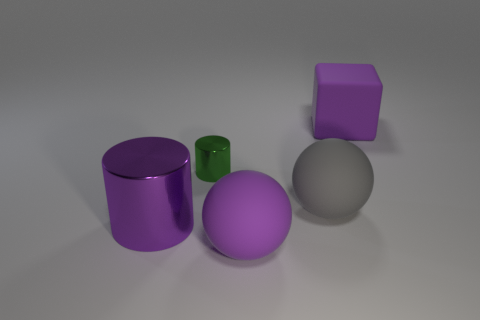Subtract 0 yellow spheres. How many objects are left? 5 Subtract all cylinders. How many objects are left? 3 Subtract 1 blocks. How many blocks are left? 0 Subtract all red balls. Subtract all cyan cylinders. How many balls are left? 2 Subtract all cyan spheres. How many red cubes are left? 0 Subtract all yellow cylinders. Subtract all big gray things. How many objects are left? 4 Add 5 matte spheres. How many matte spheres are left? 7 Add 5 purple rubber blocks. How many purple rubber blocks exist? 6 Add 2 tiny green metallic objects. How many objects exist? 7 Subtract all purple spheres. How many spheres are left? 1 